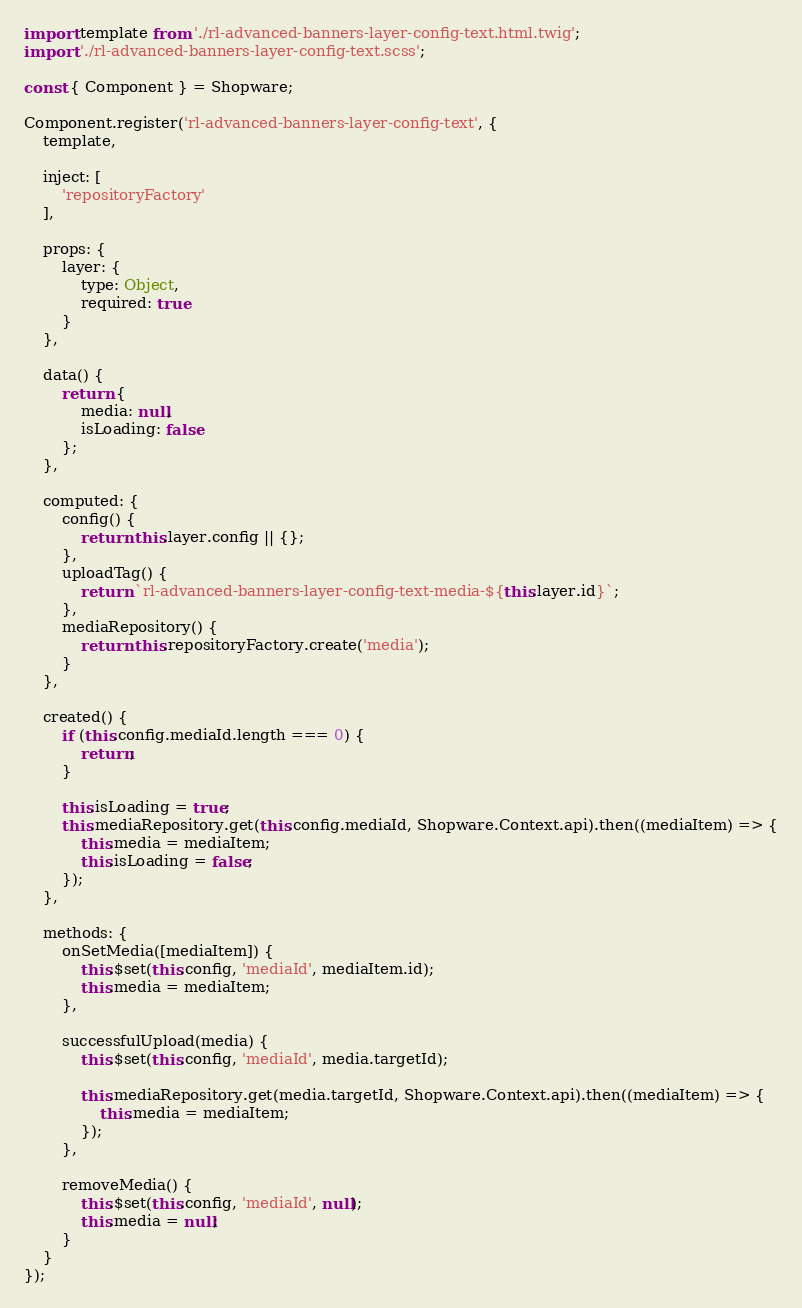Convert code to text. <code><loc_0><loc_0><loc_500><loc_500><_JavaScript_>import template from './rl-advanced-banners-layer-config-text.html.twig';
import './rl-advanced-banners-layer-config-text.scss';

const { Component } = Shopware;

Component.register('rl-advanced-banners-layer-config-text', {
    template,

    inject: [
        'repositoryFactory'
    ],

    props: {
        layer: {
            type: Object,
            required: true
        }
    },

    data() {
        return {
            media: null,
            isLoading: false
        };
    },

    computed: {
        config() {
            return this.layer.config || {};
        },
        uploadTag() {
            return `rl-advanced-banners-layer-config-text-media-${this.layer.id}`;
        },
        mediaRepository() {
            return this.repositoryFactory.create('media');
        }
    },

    created() {
        if (this.config.mediaId.length === 0) {
            return;
        }

        this.isLoading = true;
        this.mediaRepository.get(this.config.mediaId, Shopware.Context.api).then((mediaItem) => {
            this.media = mediaItem;
            this.isLoading = false;
        });
    },

    methods: {
        onSetMedia([mediaItem]) {
            this.$set(this.config, 'mediaId', mediaItem.id);
            this.media = mediaItem;
        },

        successfulUpload(media) {
            this.$set(this.config, 'mediaId', media.targetId);

            this.mediaRepository.get(media.targetId, Shopware.Context.api).then((mediaItem) => {
                this.media = mediaItem;
            });
        },

        removeMedia() {
            this.$set(this.config, 'mediaId', null);
            this.media = null;
        }
    }
});
</code> 